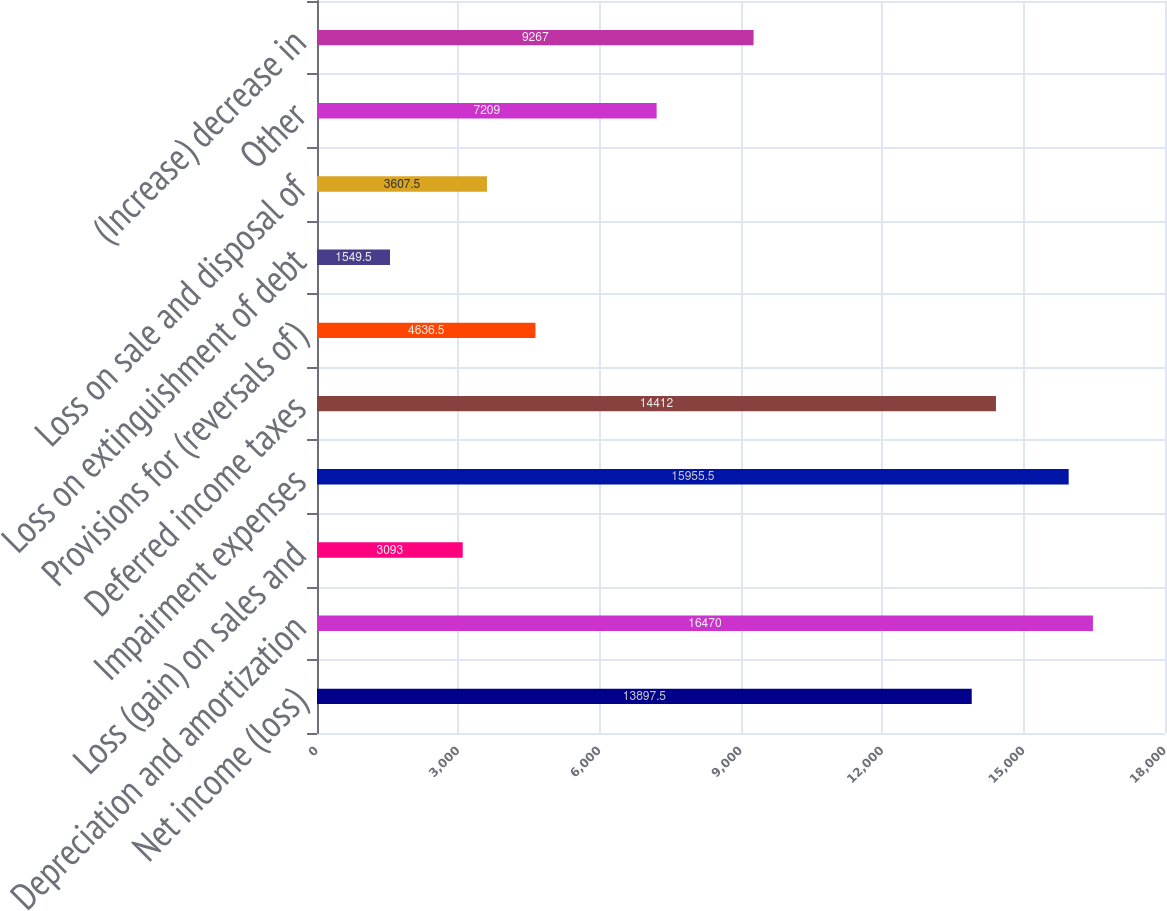Convert chart. <chart><loc_0><loc_0><loc_500><loc_500><bar_chart><fcel>Net income (loss)<fcel>Depreciation and amortization<fcel>Loss (gain) on sales and<fcel>Impairment expenses<fcel>Deferred income taxes<fcel>Provisions for (reversals of)<fcel>Loss on extinguishment of debt<fcel>Loss on sale and disposal of<fcel>Other<fcel>(Increase) decrease in<nl><fcel>13897.5<fcel>16470<fcel>3093<fcel>15955.5<fcel>14412<fcel>4636.5<fcel>1549.5<fcel>3607.5<fcel>7209<fcel>9267<nl></chart> 